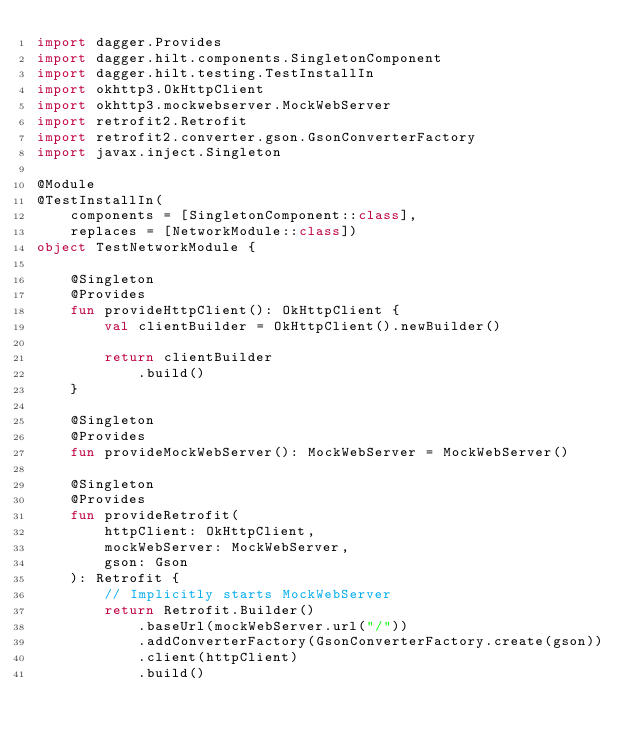<code> <loc_0><loc_0><loc_500><loc_500><_Kotlin_>import dagger.Provides
import dagger.hilt.components.SingletonComponent
import dagger.hilt.testing.TestInstallIn
import okhttp3.OkHttpClient
import okhttp3.mockwebserver.MockWebServer
import retrofit2.Retrofit
import retrofit2.converter.gson.GsonConverterFactory
import javax.inject.Singleton

@Module
@TestInstallIn(
    components = [SingletonComponent::class],
    replaces = [NetworkModule::class])
object TestNetworkModule {

    @Singleton
    @Provides
    fun provideHttpClient(): OkHttpClient {
        val clientBuilder = OkHttpClient().newBuilder()

        return clientBuilder
            .build()
    }

    @Singleton
    @Provides
    fun provideMockWebServer(): MockWebServer = MockWebServer()

    @Singleton
    @Provides
    fun provideRetrofit(
        httpClient: OkHttpClient,
        mockWebServer: MockWebServer,
        gson: Gson
    ): Retrofit {
        // Implicitly starts MockWebServer
        return Retrofit.Builder()
            .baseUrl(mockWebServer.url("/"))
            .addConverterFactory(GsonConverterFactory.create(gson))
            .client(httpClient)
            .build()</code> 